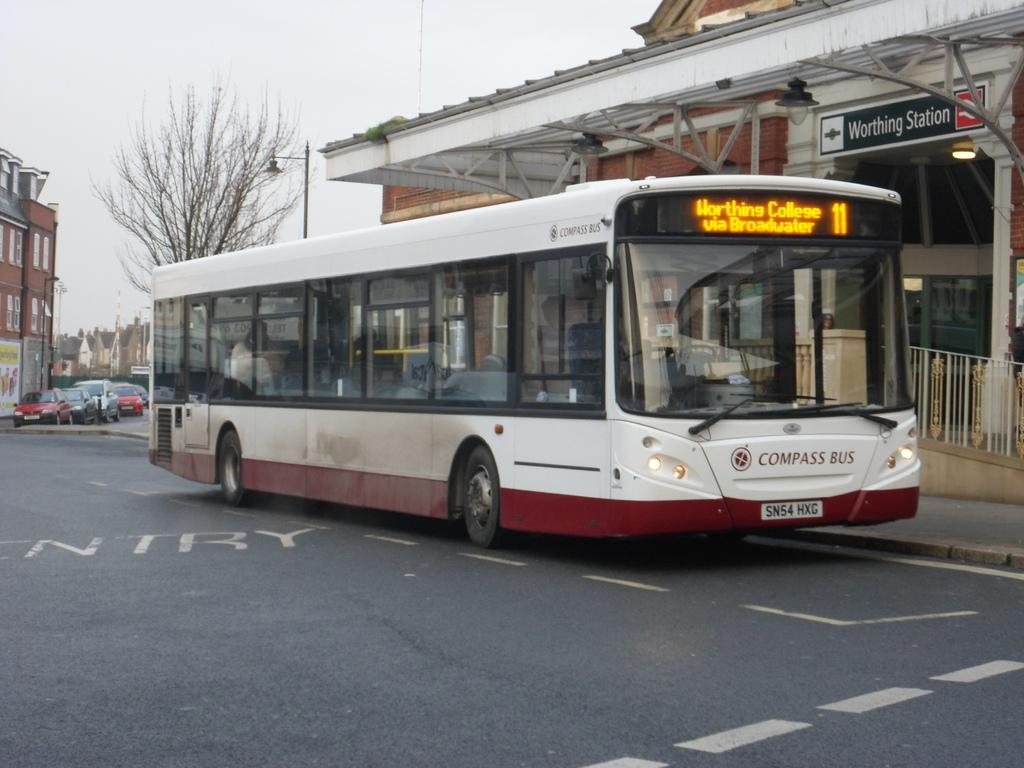<image>
Relay a brief, clear account of the picture shown. A Compass Bus is sitting at the Worthing Station 